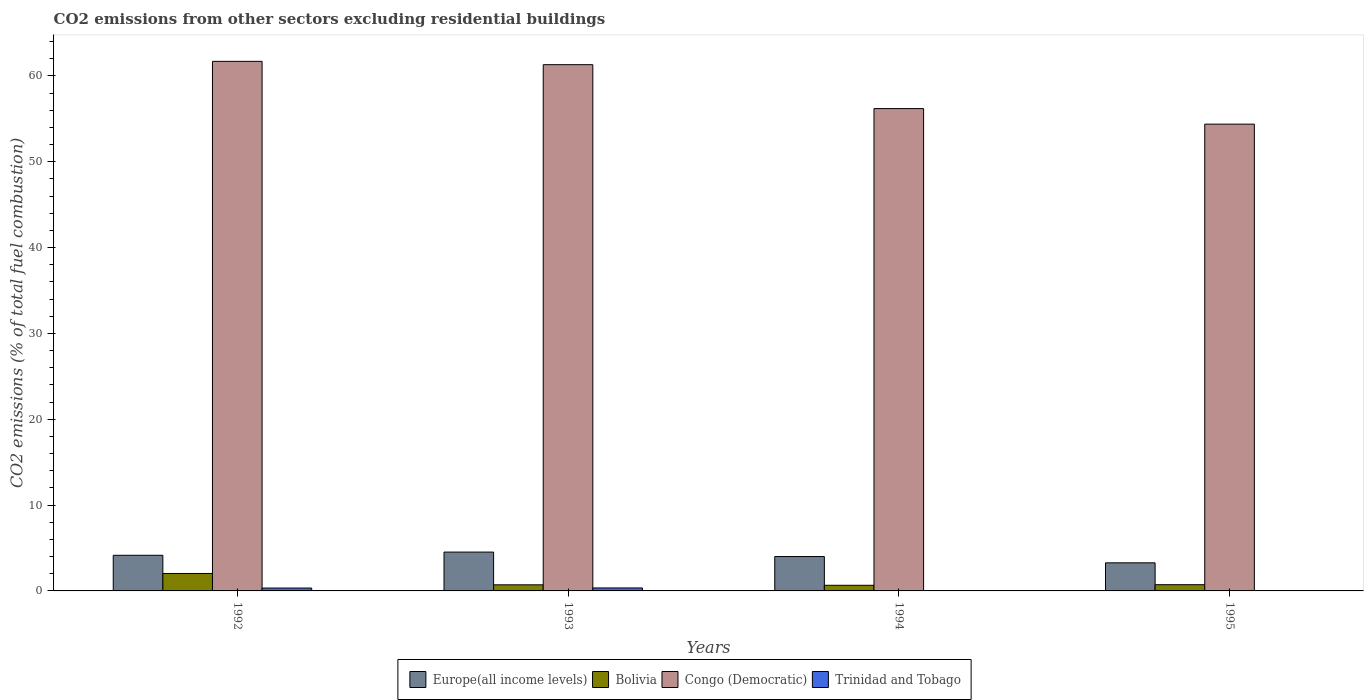How many different coloured bars are there?
Provide a short and direct response. 4. How many groups of bars are there?
Ensure brevity in your answer.  4. How many bars are there on the 4th tick from the left?
Ensure brevity in your answer.  3. How many bars are there on the 4th tick from the right?
Offer a terse response. 4. What is the label of the 2nd group of bars from the left?
Make the answer very short. 1993. In how many cases, is the number of bars for a given year not equal to the number of legend labels?
Offer a very short reply. 2. What is the total CO2 emitted in Congo (Democratic) in 1994?
Ensure brevity in your answer.  56.2. Across all years, what is the maximum total CO2 emitted in Congo (Democratic)?
Keep it short and to the point. 61.7. Across all years, what is the minimum total CO2 emitted in Europe(all income levels)?
Provide a short and direct response. 3.27. In which year was the total CO2 emitted in Europe(all income levels) maximum?
Keep it short and to the point. 1993. What is the total total CO2 emitted in Trinidad and Tobago in the graph?
Provide a short and direct response. 0.68. What is the difference between the total CO2 emitted in Congo (Democratic) in 1992 and that in 1994?
Your answer should be compact. 5.5. What is the difference between the total CO2 emitted in Bolivia in 1992 and the total CO2 emitted in Trinidad and Tobago in 1994?
Your response must be concise. 2.03. What is the average total CO2 emitted in Congo (Democratic) per year?
Give a very brief answer. 58.4. In the year 1993, what is the difference between the total CO2 emitted in Europe(all income levels) and total CO2 emitted in Bolivia?
Your answer should be compact. 3.81. In how many years, is the total CO2 emitted in Europe(all income levels) greater than 22?
Offer a very short reply. 0. What is the ratio of the total CO2 emitted in Europe(all income levels) in 1993 to that in 1994?
Offer a very short reply. 1.13. Is the difference between the total CO2 emitted in Europe(all income levels) in 1993 and 1995 greater than the difference between the total CO2 emitted in Bolivia in 1993 and 1995?
Ensure brevity in your answer.  Yes. What is the difference between the highest and the second highest total CO2 emitted in Congo (Democratic)?
Provide a succinct answer. 0.39. What is the difference between the highest and the lowest total CO2 emitted in Trinidad and Tobago?
Provide a succinct answer. 0.35. In how many years, is the total CO2 emitted in Bolivia greater than the average total CO2 emitted in Bolivia taken over all years?
Give a very brief answer. 1. Is it the case that in every year, the sum of the total CO2 emitted in Europe(all income levels) and total CO2 emitted in Congo (Democratic) is greater than the sum of total CO2 emitted in Trinidad and Tobago and total CO2 emitted in Bolivia?
Give a very brief answer. Yes. How many bars are there?
Your answer should be compact. 14. Are all the bars in the graph horizontal?
Give a very brief answer. No. How many years are there in the graph?
Give a very brief answer. 4. Are the values on the major ticks of Y-axis written in scientific E-notation?
Provide a short and direct response. No. Where does the legend appear in the graph?
Ensure brevity in your answer.  Bottom center. How are the legend labels stacked?
Offer a terse response. Horizontal. What is the title of the graph?
Ensure brevity in your answer.  CO2 emissions from other sectors excluding residential buildings. What is the label or title of the X-axis?
Give a very brief answer. Years. What is the label or title of the Y-axis?
Give a very brief answer. CO2 emissions (% of total fuel combustion). What is the CO2 emissions (% of total fuel combustion) of Europe(all income levels) in 1992?
Offer a very short reply. 4.15. What is the CO2 emissions (% of total fuel combustion) in Bolivia in 1992?
Your answer should be very brief. 2.03. What is the CO2 emissions (% of total fuel combustion) of Congo (Democratic) in 1992?
Provide a short and direct response. 61.7. What is the CO2 emissions (% of total fuel combustion) of Trinidad and Tobago in 1992?
Your answer should be compact. 0.33. What is the CO2 emissions (% of total fuel combustion) in Europe(all income levels) in 1993?
Your answer should be compact. 4.52. What is the CO2 emissions (% of total fuel combustion) in Bolivia in 1993?
Make the answer very short. 0.71. What is the CO2 emissions (% of total fuel combustion) in Congo (Democratic) in 1993?
Your answer should be very brief. 61.31. What is the CO2 emissions (% of total fuel combustion) in Trinidad and Tobago in 1993?
Give a very brief answer. 0.35. What is the CO2 emissions (% of total fuel combustion) in Europe(all income levels) in 1994?
Provide a short and direct response. 4.01. What is the CO2 emissions (% of total fuel combustion) in Bolivia in 1994?
Make the answer very short. 0.66. What is the CO2 emissions (% of total fuel combustion) of Congo (Democratic) in 1994?
Make the answer very short. 56.2. What is the CO2 emissions (% of total fuel combustion) in Trinidad and Tobago in 1994?
Your answer should be very brief. 0. What is the CO2 emissions (% of total fuel combustion) in Europe(all income levels) in 1995?
Provide a short and direct response. 3.27. What is the CO2 emissions (% of total fuel combustion) in Bolivia in 1995?
Provide a short and direct response. 0.73. What is the CO2 emissions (% of total fuel combustion) of Congo (Democratic) in 1995?
Make the answer very short. 54.39. What is the CO2 emissions (% of total fuel combustion) in Trinidad and Tobago in 1995?
Offer a very short reply. 0. Across all years, what is the maximum CO2 emissions (% of total fuel combustion) of Europe(all income levels)?
Ensure brevity in your answer.  4.52. Across all years, what is the maximum CO2 emissions (% of total fuel combustion) in Bolivia?
Make the answer very short. 2.03. Across all years, what is the maximum CO2 emissions (% of total fuel combustion) in Congo (Democratic)?
Give a very brief answer. 61.7. Across all years, what is the maximum CO2 emissions (% of total fuel combustion) of Trinidad and Tobago?
Keep it short and to the point. 0.35. Across all years, what is the minimum CO2 emissions (% of total fuel combustion) in Europe(all income levels)?
Provide a succinct answer. 3.27. Across all years, what is the minimum CO2 emissions (% of total fuel combustion) of Bolivia?
Give a very brief answer. 0.66. Across all years, what is the minimum CO2 emissions (% of total fuel combustion) in Congo (Democratic)?
Keep it short and to the point. 54.39. Across all years, what is the minimum CO2 emissions (% of total fuel combustion) in Trinidad and Tobago?
Provide a succinct answer. 0. What is the total CO2 emissions (% of total fuel combustion) in Europe(all income levels) in the graph?
Your response must be concise. 15.95. What is the total CO2 emissions (% of total fuel combustion) in Bolivia in the graph?
Provide a short and direct response. 4.13. What is the total CO2 emissions (% of total fuel combustion) in Congo (Democratic) in the graph?
Your answer should be compact. 233.6. What is the total CO2 emissions (% of total fuel combustion) in Trinidad and Tobago in the graph?
Give a very brief answer. 0.68. What is the difference between the CO2 emissions (% of total fuel combustion) of Europe(all income levels) in 1992 and that in 1993?
Offer a very short reply. -0.37. What is the difference between the CO2 emissions (% of total fuel combustion) of Bolivia in 1992 and that in 1993?
Offer a very short reply. 1.32. What is the difference between the CO2 emissions (% of total fuel combustion) of Congo (Democratic) in 1992 and that in 1993?
Provide a succinct answer. 0.39. What is the difference between the CO2 emissions (% of total fuel combustion) in Trinidad and Tobago in 1992 and that in 1993?
Make the answer very short. -0.01. What is the difference between the CO2 emissions (% of total fuel combustion) of Europe(all income levels) in 1992 and that in 1994?
Your answer should be compact. 0.15. What is the difference between the CO2 emissions (% of total fuel combustion) of Bolivia in 1992 and that in 1994?
Your response must be concise. 1.38. What is the difference between the CO2 emissions (% of total fuel combustion) of Congo (Democratic) in 1992 and that in 1994?
Make the answer very short. 5.5. What is the difference between the CO2 emissions (% of total fuel combustion) of Europe(all income levels) in 1992 and that in 1995?
Ensure brevity in your answer.  0.88. What is the difference between the CO2 emissions (% of total fuel combustion) in Bolivia in 1992 and that in 1995?
Make the answer very short. 1.31. What is the difference between the CO2 emissions (% of total fuel combustion) in Congo (Democratic) in 1992 and that in 1995?
Keep it short and to the point. 7.32. What is the difference between the CO2 emissions (% of total fuel combustion) in Europe(all income levels) in 1993 and that in 1994?
Give a very brief answer. 0.52. What is the difference between the CO2 emissions (% of total fuel combustion) in Bolivia in 1993 and that in 1994?
Your answer should be very brief. 0.06. What is the difference between the CO2 emissions (% of total fuel combustion) of Congo (Democratic) in 1993 and that in 1994?
Make the answer very short. 5.12. What is the difference between the CO2 emissions (% of total fuel combustion) in Europe(all income levels) in 1993 and that in 1995?
Provide a short and direct response. 1.25. What is the difference between the CO2 emissions (% of total fuel combustion) in Bolivia in 1993 and that in 1995?
Make the answer very short. -0.01. What is the difference between the CO2 emissions (% of total fuel combustion) in Congo (Democratic) in 1993 and that in 1995?
Make the answer very short. 6.93. What is the difference between the CO2 emissions (% of total fuel combustion) of Europe(all income levels) in 1994 and that in 1995?
Offer a terse response. 0.73. What is the difference between the CO2 emissions (% of total fuel combustion) in Bolivia in 1994 and that in 1995?
Offer a terse response. -0.07. What is the difference between the CO2 emissions (% of total fuel combustion) in Congo (Democratic) in 1994 and that in 1995?
Provide a short and direct response. 1.81. What is the difference between the CO2 emissions (% of total fuel combustion) in Europe(all income levels) in 1992 and the CO2 emissions (% of total fuel combustion) in Bolivia in 1993?
Provide a succinct answer. 3.44. What is the difference between the CO2 emissions (% of total fuel combustion) of Europe(all income levels) in 1992 and the CO2 emissions (% of total fuel combustion) of Congo (Democratic) in 1993?
Keep it short and to the point. -57.16. What is the difference between the CO2 emissions (% of total fuel combustion) of Europe(all income levels) in 1992 and the CO2 emissions (% of total fuel combustion) of Trinidad and Tobago in 1993?
Your response must be concise. 3.81. What is the difference between the CO2 emissions (% of total fuel combustion) in Bolivia in 1992 and the CO2 emissions (% of total fuel combustion) in Congo (Democratic) in 1993?
Keep it short and to the point. -59.28. What is the difference between the CO2 emissions (% of total fuel combustion) in Bolivia in 1992 and the CO2 emissions (% of total fuel combustion) in Trinidad and Tobago in 1993?
Provide a short and direct response. 1.69. What is the difference between the CO2 emissions (% of total fuel combustion) in Congo (Democratic) in 1992 and the CO2 emissions (% of total fuel combustion) in Trinidad and Tobago in 1993?
Offer a very short reply. 61.36. What is the difference between the CO2 emissions (% of total fuel combustion) of Europe(all income levels) in 1992 and the CO2 emissions (% of total fuel combustion) of Bolivia in 1994?
Ensure brevity in your answer.  3.5. What is the difference between the CO2 emissions (% of total fuel combustion) of Europe(all income levels) in 1992 and the CO2 emissions (% of total fuel combustion) of Congo (Democratic) in 1994?
Provide a short and direct response. -52.05. What is the difference between the CO2 emissions (% of total fuel combustion) in Bolivia in 1992 and the CO2 emissions (% of total fuel combustion) in Congo (Democratic) in 1994?
Your answer should be compact. -54.17. What is the difference between the CO2 emissions (% of total fuel combustion) of Europe(all income levels) in 1992 and the CO2 emissions (% of total fuel combustion) of Bolivia in 1995?
Give a very brief answer. 3.43. What is the difference between the CO2 emissions (% of total fuel combustion) in Europe(all income levels) in 1992 and the CO2 emissions (% of total fuel combustion) in Congo (Democratic) in 1995?
Your response must be concise. -50.23. What is the difference between the CO2 emissions (% of total fuel combustion) in Bolivia in 1992 and the CO2 emissions (% of total fuel combustion) in Congo (Democratic) in 1995?
Your answer should be very brief. -52.35. What is the difference between the CO2 emissions (% of total fuel combustion) in Europe(all income levels) in 1993 and the CO2 emissions (% of total fuel combustion) in Bolivia in 1994?
Ensure brevity in your answer.  3.87. What is the difference between the CO2 emissions (% of total fuel combustion) of Europe(all income levels) in 1993 and the CO2 emissions (% of total fuel combustion) of Congo (Democratic) in 1994?
Ensure brevity in your answer.  -51.67. What is the difference between the CO2 emissions (% of total fuel combustion) of Bolivia in 1993 and the CO2 emissions (% of total fuel combustion) of Congo (Democratic) in 1994?
Offer a terse response. -55.49. What is the difference between the CO2 emissions (% of total fuel combustion) in Europe(all income levels) in 1993 and the CO2 emissions (% of total fuel combustion) in Bolivia in 1995?
Provide a succinct answer. 3.8. What is the difference between the CO2 emissions (% of total fuel combustion) of Europe(all income levels) in 1993 and the CO2 emissions (% of total fuel combustion) of Congo (Democratic) in 1995?
Make the answer very short. -49.86. What is the difference between the CO2 emissions (% of total fuel combustion) of Bolivia in 1993 and the CO2 emissions (% of total fuel combustion) of Congo (Democratic) in 1995?
Keep it short and to the point. -53.67. What is the difference between the CO2 emissions (% of total fuel combustion) in Europe(all income levels) in 1994 and the CO2 emissions (% of total fuel combustion) in Bolivia in 1995?
Offer a terse response. 3.28. What is the difference between the CO2 emissions (% of total fuel combustion) of Europe(all income levels) in 1994 and the CO2 emissions (% of total fuel combustion) of Congo (Democratic) in 1995?
Make the answer very short. -50.38. What is the difference between the CO2 emissions (% of total fuel combustion) in Bolivia in 1994 and the CO2 emissions (% of total fuel combustion) in Congo (Democratic) in 1995?
Offer a terse response. -53.73. What is the average CO2 emissions (% of total fuel combustion) of Europe(all income levels) per year?
Give a very brief answer. 3.99. What is the average CO2 emissions (% of total fuel combustion) in Bolivia per year?
Your answer should be very brief. 1.03. What is the average CO2 emissions (% of total fuel combustion) in Congo (Democratic) per year?
Ensure brevity in your answer.  58.4. What is the average CO2 emissions (% of total fuel combustion) of Trinidad and Tobago per year?
Your answer should be very brief. 0.17. In the year 1992, what is the difference between the CO2 emissions (% of total fuel combustion) of Europe(all income levels) and CO2 emissions (% of total fuel combustion) of Bolivia?
Provide a short and direct response. 2.12. In the year 1992, what is the difference between the CO2 emissions (% of total fuel combustion) of Europe(all income levels) and CO2 emissions (% of total fuel combustion) of Congo (Democratic)?
Your answer should be very brief. -57.55. In the year 1992, what is the difference between the CO2 emissions (% of total fuel combustion) of Europe(all income levels) and CO2 emissions (% of total fuel combustion) of Trinidad and Tobago?
Offer a terse response. 3.82. In the year 1992, what is the difference between the CO2 emissions (% of total fuel combustion) in Bolivia and CO2 emissions (% of total fuel combustion) in Congo (Democratic)?
Offer a very short reply. -59.67. In the year 1992, what is the difference between the CO2 emissions (% of total fuel combustion) in Bolivia and CO2 emissions (% of total fuel combustion) in Trinidad and Tobago?
Provide a succinct answer. 1.7. In the year 1992, what is the difference between the CO2 emissions (% of total fuel combustion) of Congo (Democratic) and CO2 emissions (% of total fuel combustion) of Trinidad and Tobago?
Ensure brevity in your answer.  61.37. In the year 1993, what is the difference between the CO2 emissions (% of total fuel combustion) in Europe(all income levels) and CO2 emissions (% of total fuel combustion) in Bolivia?
Give a very brief answer. 3.81. In the year 1993, what is the difference between the CO2 emissions (% of total fuel combustion) of Europe(all income levels) and CO2 emissions (% of total fuel combustion) of Congo (Democratic)?
Your response must be concise. -56.79. In the year 1993, what is the difference between the CO2 emissions (% of total fuel combustion) in Europe(all income levels) and CO2 emissions (% of total fuel combustion) in Trinidad and Tobago?
Your response must be concise. 4.18. In the year 1993, what is the difference between the CO2 emissions (% of total fuel combustion) in Bolivia and CO2 emissions (% of total fuel combustion) in Congo (Democratic)?
Provide a succinct answer. -60.6. In the year 1993, what is the difference between the CO2 emissions (% of total fuel combustion) in Bolivia and CO2 emissions (% of total fuel combustion) in Trinidad and Tobago?
Ensure brevity in your answer.  0.37. In the year 1993, what is the difference between the CO2 emissions (% of total fuel combustion) of Congo (Democratic) and CO2 emissions (% of total fuel combustion) of Trinidad and Tobago?
Offer a terse response. 60.97. In the year 1994, what is the difference between the CO2 emissions (% of total fuel combustion) of Europe(all income levels) and CO2 emissions (% of total fuel combustion) of Bolivia?
Keep it short and to the point. 3.35. In the year 1994, what is the difference between the CO2 emissions (% of total fuel combustion) of Europe(all income levels) and CO2 emissions (% of total fuel combustion) of Congo (Democratic)?
Keep it short and to the point. -52.19. In the year 1994, what is the difference between the CO2 emissions (% of total fuel combustion) in Bolivia and CO2 emissions (% of total fuel combustion) in Congo (Democratic)?
Keep it short and to the point. -55.54. In the year 1995, what is the difference between the CO2 emissions (% of total fuel combustion) of Europe(all income levels) and CO2 emissions (% of total fuel combustion) of Bolivia?
Keep it short and to the point. 2.55. In the year 1995, what is the difference between the CO2 emissions (% of total fuel combustion) in Europe(all income levels) and CO2 emissions (% of total fuel combustion) in Congo (Democratic)?
Ensure brevity in your answer.  -51.11. In the year 1995, what is the difference between the CO2 emissions (% of total fuel combustion) of Bolivia and CO2 emissions (% of total fuel combustion) of Congo (Democratic)?
Offer a very short reply. -53.66. What is the ratio of the CO2 emissions (% of total fuel combustion) of Europe(all income levels) in 1992 to that in 1993?
Give a very brief answer. 0.92. What is the ratio of the CO2 emissions (% of total fuel combustion) in Bolivia in 1992 to that in 1993?
Offer a terse response. 2.86. What is the ratio of the CO2 emissions (% of total fuel combustion) in Trinidad and Tobago in 1992 to that in 1993?
Keep it short and to the point. 0.97. What is the ratio of the CO2 emissions (% of total fuel combustion) of Europe(all income levels) in 1992 to that in 1994?
Provide a succinct answer. 1.04. What is the ratio of the CO2 emissions (% of total fuel combustion) in Bolivia in 1992 to that in 1994?
Give a very brief answer. 3.1. What is the ratio of the CO2 emissions (% of total fuel combustion) of Congo (Democratic) in 1992 to that in 1994?
Your answer should be compact. 1.1. What is the ratio of the CO2 emissions (% of total fuel combustion) of Europe(all income levels) in 1992 to that in 1995?
Your answer should be compact. 1.27. What is the ratio of the CO2 emissions (% of total fuel combustion) in Bolivia in 1992 to that in 1995?
Your answer should be compact. 2.8. What is the ratio of the CO2 emissions (% of total fuel combustion) in Congo (Democratic) in 1992 to that in 1995?
Make the answer very short. 1.13. What is the ratio of the CO2 emissions (% of total fuel combustion) in Europe(all income levels) in 1993 to that in 1994?
Your response must be concise. 1.13. What is the ratio of the CO2 emissions (% of total fuel combustion) in Bolivia in 1993 to that in 1994?
Offer a very short reply. 1.09. What is the ratio of the CO2 emissions (% of total fuel combustion) in Congo (Democratic) in 1993 to that in 1994?
Offer a very short reply. 1.09. What is the ratio of the CO2 emissions (% of total fuel combustion) in Europe(all income levels) in 1993 to that in 1995?
Your answer should be very brief. 1.38. What is the ratio of the CO2 emissions (% of total fuel combustion) of Bolivia in 1993 to that in 1995?
Your answer should be compact. 0.98. What is the ratio of the CO2 emissions (% of total fuel combustion) of Congo (Democratic) in 1993 to that in 1995?
Offer a very short reply. 1.13. What is the ratio of the CO2 emissions (% of total fuel combustion) of Europe(all income levels) in 1994 to that in 1995?
Make the answer very short. 1.22. What is the ratio of the CO2 emissions (% of total fuel combustion) of Bolivia in 1994 to that in 1995?
Provide a short and direct response. 0.9. What is the difference between the highest and the second highest CO2 emissions (% of total fuel combustion) in Europe(all income levels)?
Give a very brief answer. 0.37. What is the difference between the highest and the second highest CO2 emissions (% of total fuel combustion) of Bolivia?
Give a very brief answer. 1.31. What is the difference between the highest and the second highest CO2 emissions (% of total fuel combustion) of Congo (Democratic)?
Your response must be concise. 0.39. What is the difference between the highest and the lowest CO2 emissions (% of total fuel combustion) in Europe(all income levels)?
Your answer should be very brief. 1.25. What is the difference between the highest and the lowest CO2 emissions (% of total fuel combustion) in Bolivia?
Your answer should be compact. 1.38. What is the difference between the highest and the lowest CO2 emissions (% of total fuel combustion) of Congo (Democratic)?
Ensure brevity in your answer.  7.32. What is the difference between the highest and the lowest CO2 emissions (% of total fuel combustion) of Trinidad and Tobago?
Offer a very short reply. 0.35. 